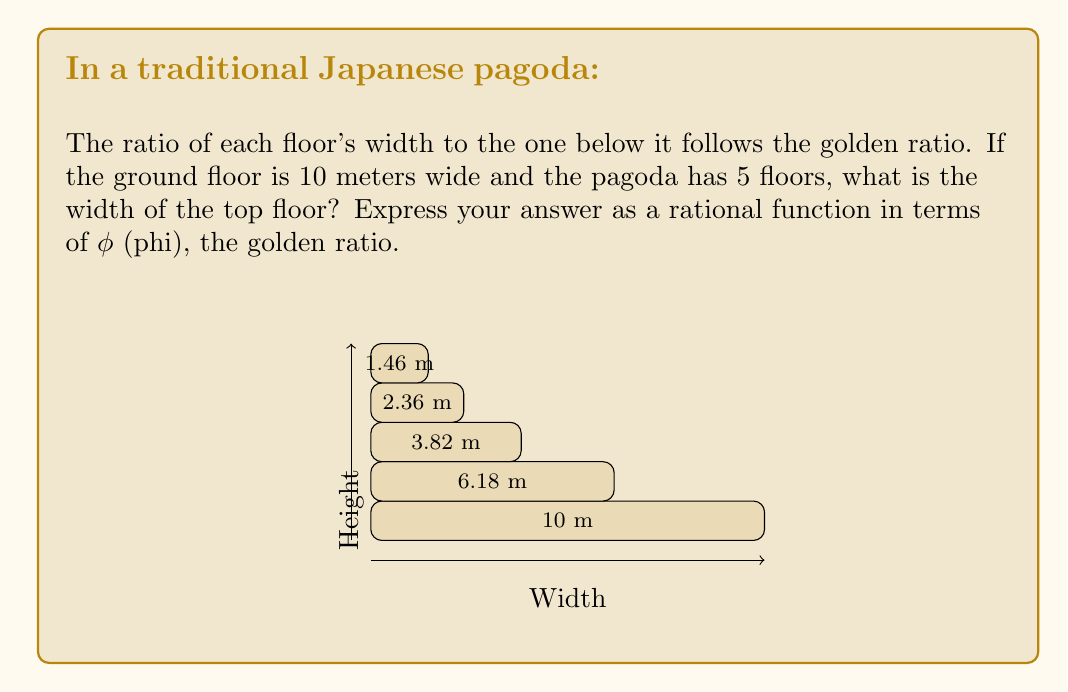Give your solution to this math problem. Let's approach this step-by-step:

1) The golden ratio, φ, is defined as:

   $$φ = \frac{1 + \sqrt{5}}{2} ≈ 1.618033989$$

2) In this pagoda, each floor's width is 1/φ times the width of the floor below it.

3) Starting from the ground floor (10 m), we can express each floor's width:
   
   Ground floor: 10 m
   2nd floor: $10 · \frac{1}{φ}$ m
   3rd floor: $10 · (\frac{1}{φ})^2$ m
   4th floor: $10 · (\frac{1}{φ})^3$ m
   5th floor (top): $10 · (\frac{1}{φ})^4$ m

4) We can simplify this expression:

   $$10 · (\frac{1}{φ})^4 = \frac{10}{φ^4}$$

5) This is already in the form of a rational function in terms of φ.
Answer: $\frac{10}{φ^4}$ meters 